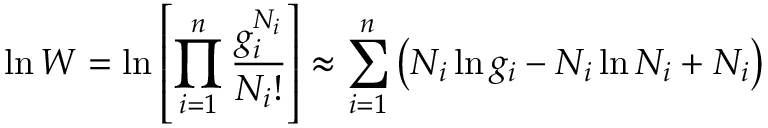<formula> <loc_0><loc_0><loc_500><loc_500>\ln W = \ln \left [ \prod _ { i = 1 } ^ { n } { \frac { g _ { i } ^ { N _ { i } } } { N _ { i } ! } } \right ] \approx \sum _ { i = 1 } ^ { n } \left ( N _ { i } \ln g _ { i } - N _ { i } \ln N _ { i } + N _ { i } \right )</formula> 